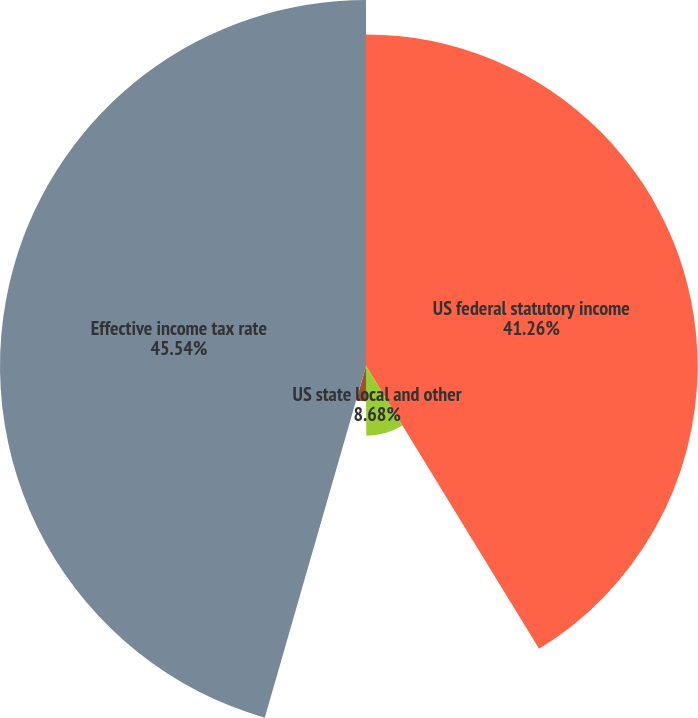<chart> <loc_0><loc_0><loc_500><loc_500><pie_chart><fcel>US federal statutory income<fcel>US state local and other<fcel>Tax credits<fcel>Other<fcel>Effective income tax rate<nl><fcel>41.26%<fcel>8.68%<fcel>4.4%<fcel>0.12%<fcel>45.54%<nl></chart> 